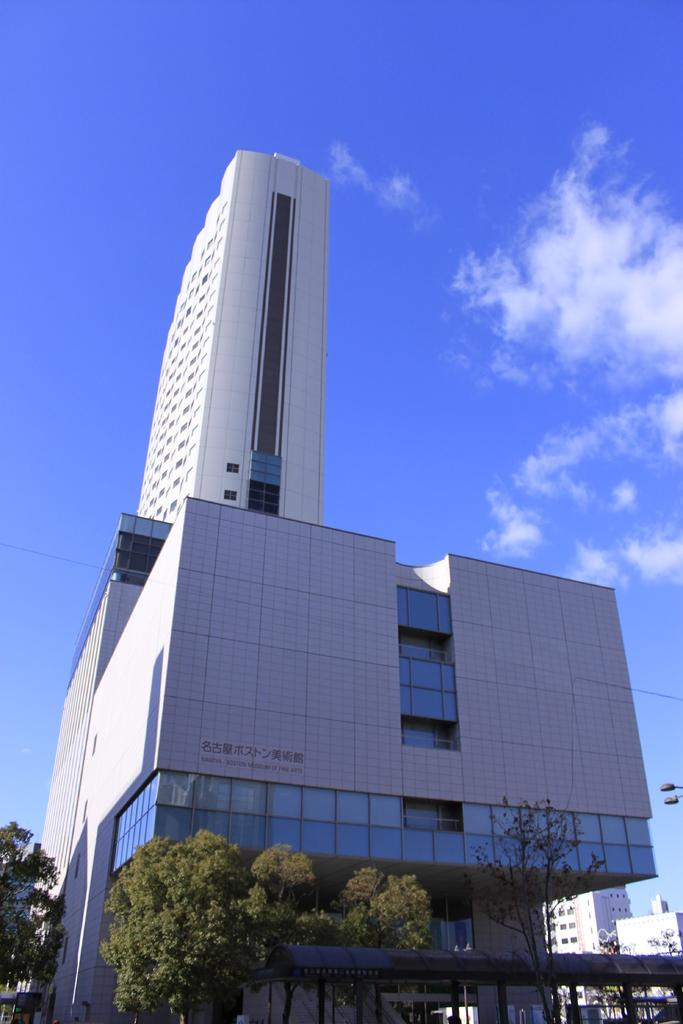What type of building is shown in the image? There is a building with many glass windows in the image. What can be seen in the background of the image? There is a white tower in the background of the image. What type of vegetation is visible in the image? There are trees visible in the image. What type of cord is being used to hold the bun in the image? There is no bun or cord present in the image. 